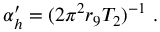Convert formula to latex. <formula><loc_0><loc_0><loc_500><loc_500>\alpha _ { h } ^ { \prime } = ( 2 \pi ^ { 2 } r _ { 9 } T _ { 2 } ) ^ { - 1 } \ .</formula> 